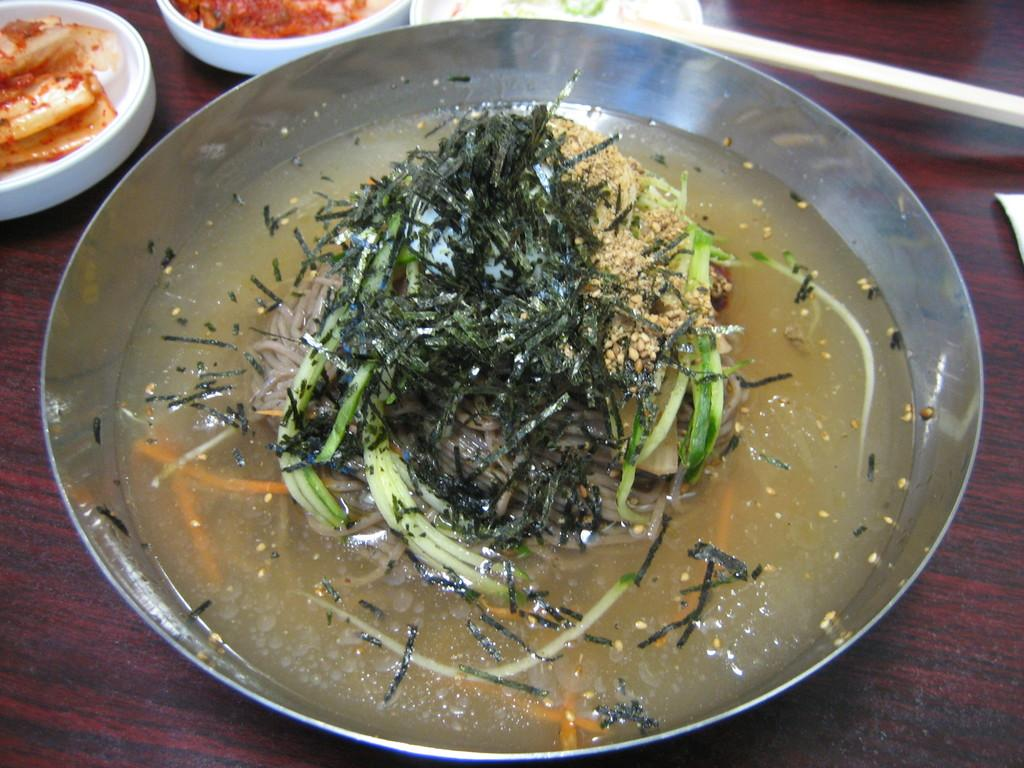What is on the plate that is visible in the image? There is food in a plate in the image. What else can be seen on the table in the image? There are bowls on the table in the image. What type of zebra is visible in the image? There is no zebra present in the image. What offer is being made in the image? The image does not depict any offers or transactions. 